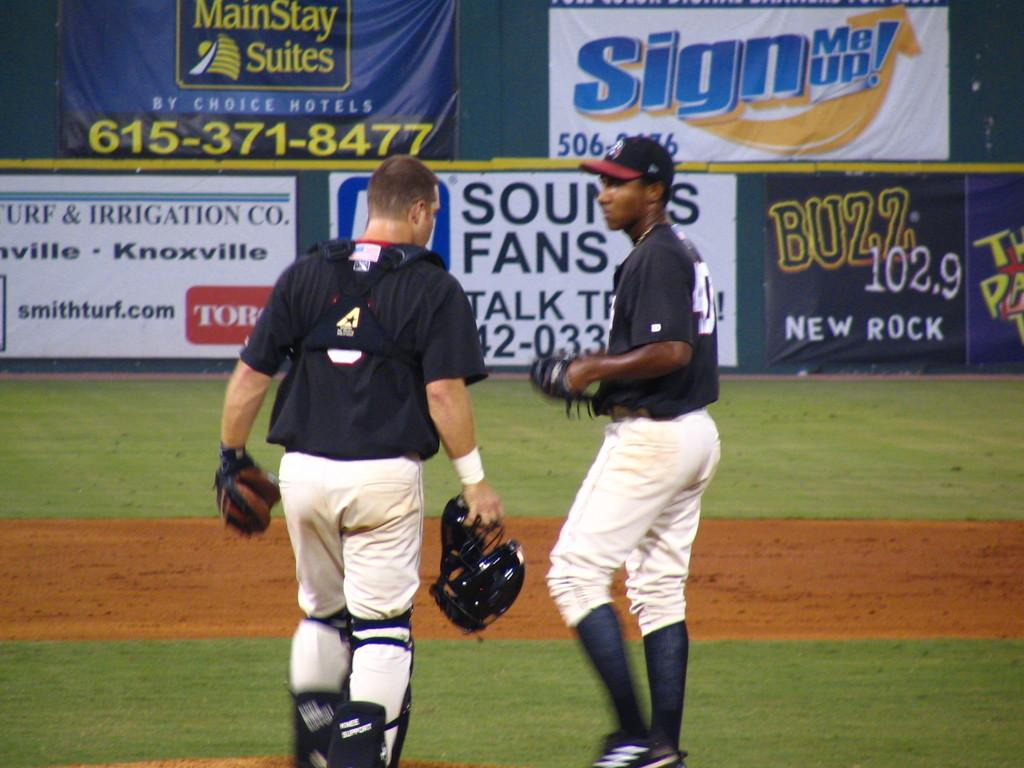<image>
Provide a brief description of the given image. The catcher and pitcher of a black and white baseball team converse on the field in front signs advertising Buzz 102.9 and smithturf.com as well as others. 